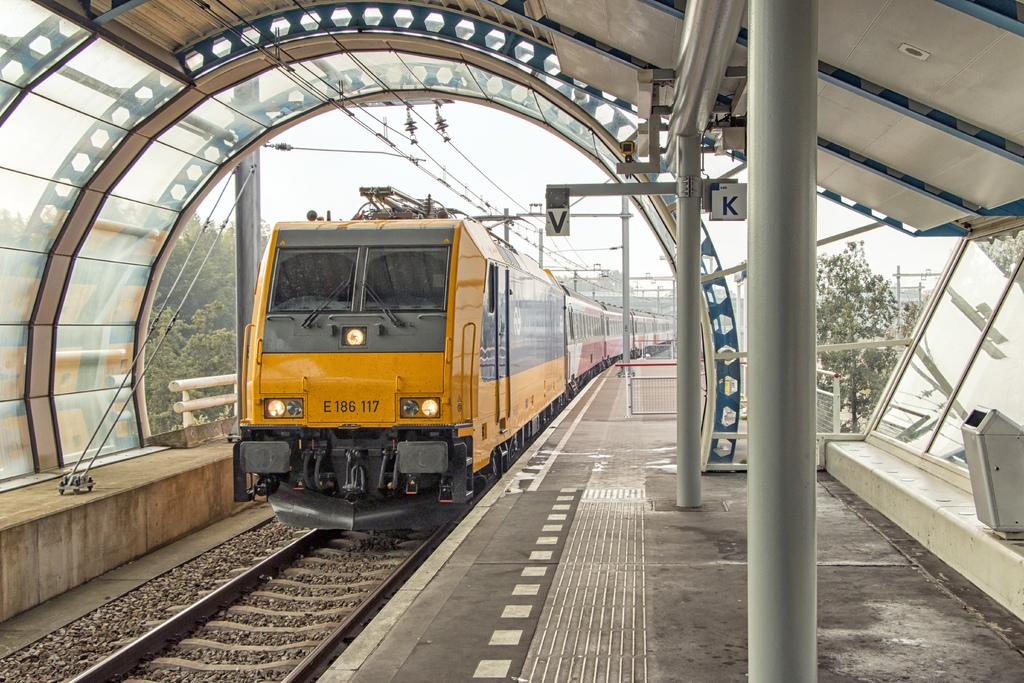What is the main subject of the image? The main subject of the image is a train. What is the train situated on? There is a train track in the image. What can be seen in the background of the image? There is an electric pole with cables in the background of the image. How many cars are parked inside the cave in the image? There is no cave or cars present in the image; it features a train on a train track with an electric pole in the background. 